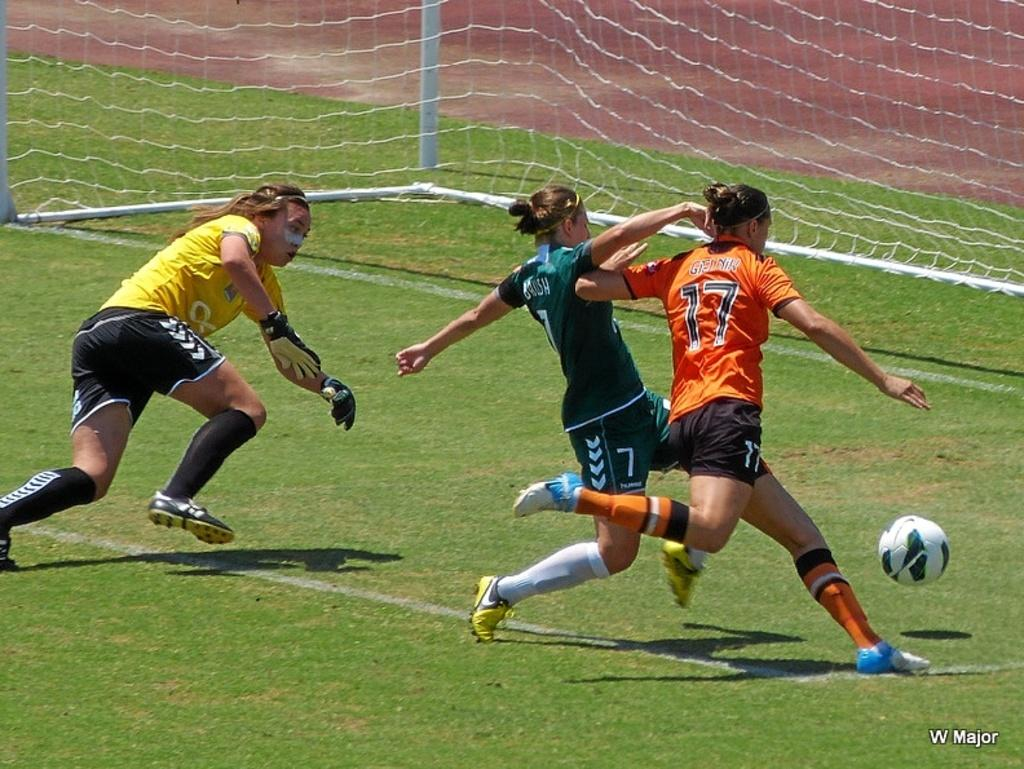How many people are present in the image? There are three women in the image. What are the women doing in the image? The women are running on the ground. What object can be seen in the image besides the women? There is a ball in the image. What type of vegetation is visible in the background of the image? There is new grass in the background of the image. What type of tank can be seen in the image? There is no tank present in the image. Is the queen visible in the image? There is no queen present in the image. 